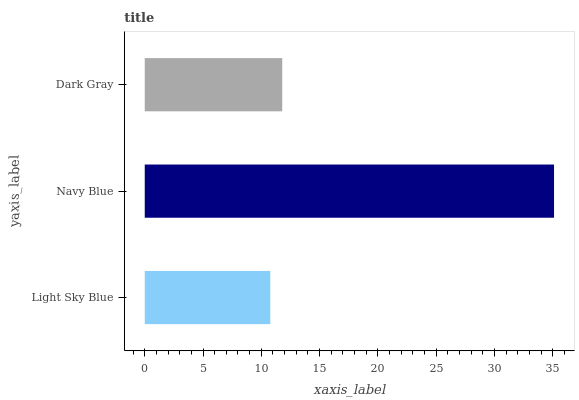Is Light Sky Blue the minimum?
Answer yes or no. Yes. Is Navy Blue the maximum?
Answer yes or no. Yes. Is Dark Gray the minimum?
Answer yes or no. No. Is Dark Gray the maximum?
Answer yes or no. No. Is Navy Blue greater than Dark Gray?
Answer yes or no. Yes. Is Dark Gray less than Navy Blue?
Answer yes or no. Yes. Is Dark Gray greater than Navy Blue?
Answer yes or no. No. Is Navy Blue less than Dark Gray?
Answer yes or no. No. Is Dark Gray the high median?
Answer yes or no. Yes. Is Dark Gray the low median?
Answer yes or no. Yes. Is Navy Blue the high median?
Answer yes or no. No. Is Light Sky Blue the low median?
Answer yes or no. No. 